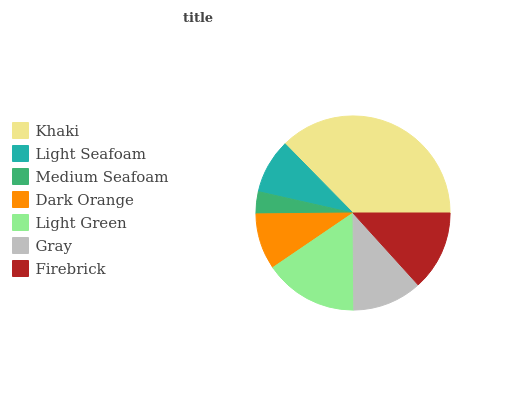Is Medium Seafoam the minimum?
Answer yes or no. Yes. Is Khaki the maximum?
Answer yes or no. Yes. Is Light Seafoam the minimum?
Answer yes or no. No. Is Light Seafoam the maximum?
Answer yes or no. No. Is Khaki greater than Light Seafoam?
Answer yes or no. Yes. Is Light Seafoam less than Khaki?
Answer yes or no. Yes. Is Light Seafoam greater than Khaki?
Answer yes or no. No. Is Khaki less than Light Seafoam?
Answer yes or no. No. Is Gray the high median?
Answer yes or no. Yes. Is Gray the low median?
Answer yes or no. Yes. Is Dark Orange the high median?
Answer yes or no. No. Is Khaki the low median?
Answer yes or no. No. 